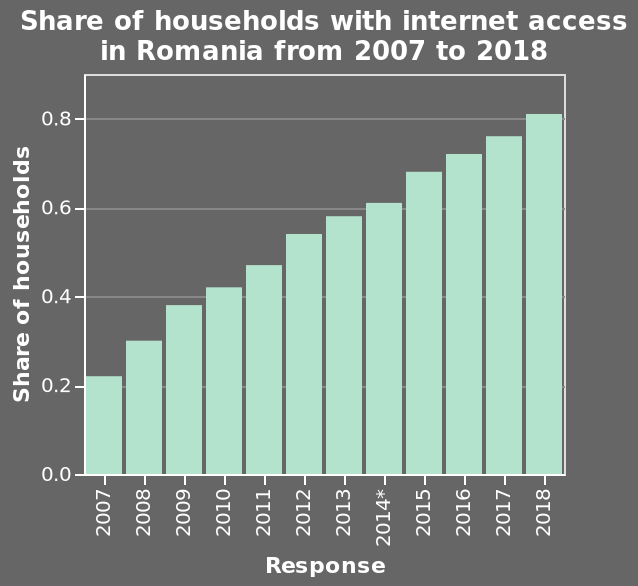<image>
Did the response rate decrease or increase in Romania annually? The response rate increased every year in Romania. please summary the statistics and relations of the chart The response rate increased every year. The share of households with internet access in Romania increased every year. What is the range of values on the y-axis? The range of values on the y-axis is from 0.0 to 0.8. Describe the following image in detail This bar graph is titled Share of households with internet access in Romania from 2007 to 2018. Along the y-axis, Share of households is drawn on a linear scale of range 0.0 to 0.8. A linear scale with a minimum of 2007 and a maximum of 2018 can be found on the x-axis, labeled Response. What is represented on the y-axis of the bar graph?  The y-axis of the bar graph represents the share of households with internet access in Romania. 